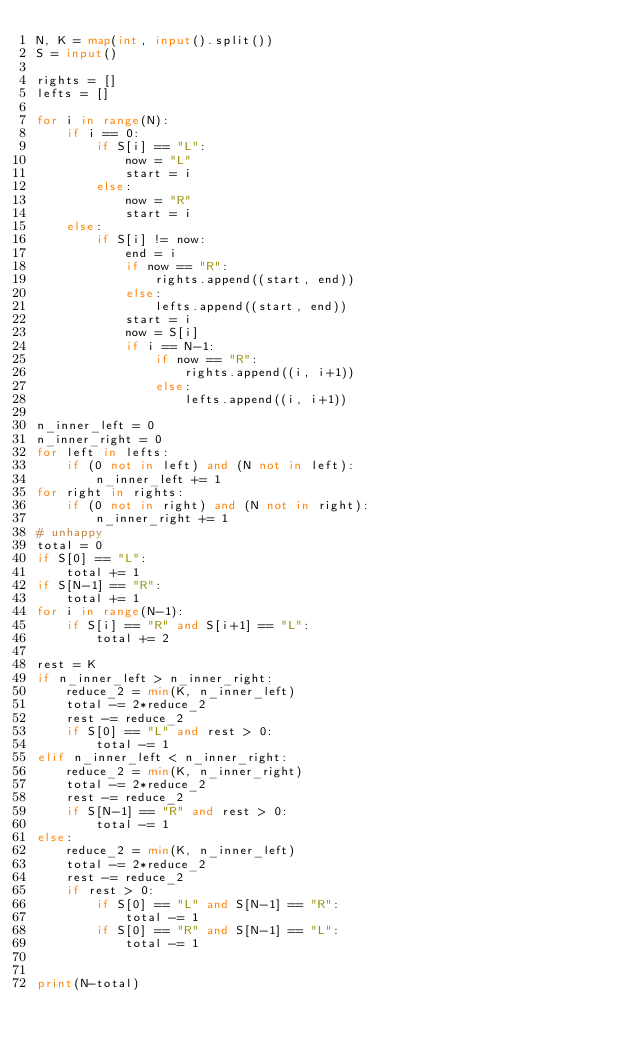<code> <loc_0><loc_0><loc_500><loc_500><_Python_>N, K = map(int, input().split())
S = input()

rights = []
lefts = []

for i in range(N):
    if i == 0:
        if S[i] == "L":
            now = "L"
            start = i
        else:
            now = "R"
            start = i
    else:
        if S[i] != now:
            end = i
            if now == "R":
                rights.append((start, end))
            else:
                lefts.append((start, end))
            start = i
            now = S[i]
            if i == N-1:
                if now == "R":
                    rights.append((i, i+1))
                else:
                    lefts.append((i, i+1))

n_inner_left = 0
n_inner_right = 0
for left in lefts:
    if (0 not in left) and (N not in left):
        n_inner_left += 1
for right in rights:
    if (0 not in right) and (N not in right):
        n_inner_right += 1
# unhappy
total = 0
if S[0] == "L":
    total += 1
if S[N-1] == "R":
    total += 1
for i in range(N-1):
    if S[i] == "R" and S[i+1] == "L":
        total += 2

rest = K
if n_inner_left > n_inner_right:
    reduce_2 = min(K, n_inner_left)
    total -= 2*reduce_2
    rest -= reduce_2
    if S[0] == "L" and rest > 0:
        total -= 1
elif n_inner_left < n_inner_right:
    reduce_2 = min(K, n_inner_right)
    total -= 2*reduce_2
    rest -= reduce_2
    if S[N-1] == "R" and rest > 0:
        total -= 1
else:
    reduce_2 = min(K, n_inner_left)
    total -= 2*reduce_2
    rest -= reduce_2
    if rest > 0:
        if S[0] == "L" and S[N-1] == "R":
            total -= 1
        if S[0] == "R" and S[N-1] == "L":
            total -= 1


print(N-total)</code> 